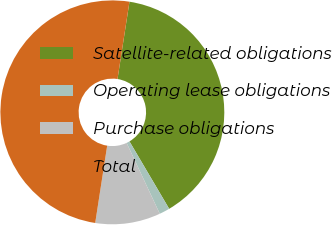Convert chart. <chart><loc_0><loc_0><loc_500><loc_500><pie_chart><fcel>Satellite-related obligations<fcel>Operating lease obligations<fcel>Purchase obligations<fcel>Total<nl><fcel>39.08%<fcel>1.51%<fcel>9.41%<fcel>50.0%<nl></chart> 